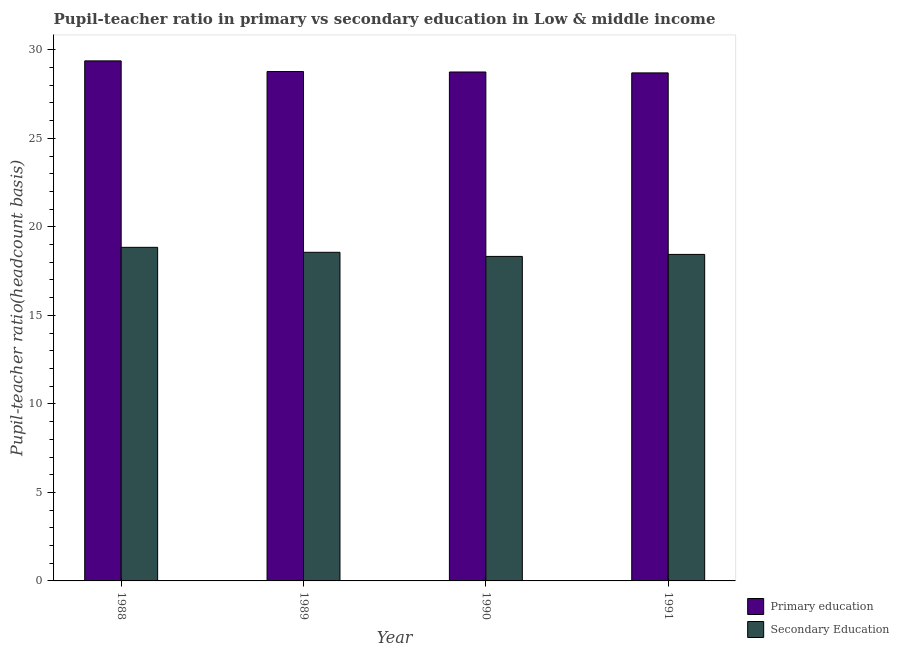How many different coloured bars are there?
Offer a terse response. 2. Are the number of bars per tick equal to the number of legend labels?
Make the answer very short. Yes. Are the number of bars on each tick of the X-axis equal?
Provide a short and direct response. Yes. How many bars are there on the 1st tick from the left?
Ensure brevity in your answer.  2. What is the pupil teacher ratio on secondary education in 1988?
Provide a succinct answer. 18.84. Across all years, what is the maximum pupil-teacher ratio in primary education?
Provide a succinct answer. 29.38. Across all years, what is the minimum pupil-teacher ratio in primary education?
Offer a very short reply. 28.7. What is the total pupil teacher ratio on secondary education in the graph?
Keep it short and to the point. 74.18. What is the difference between the pupil-teacher ratio in primary education in 1989 and that in 1990?
Provide a succinct answer. 0.03. What is the difference between the pupil teacher ratio on secondary education in 1990 and the pupil-teacher ratio in primary education in 1991?
Give a very brief answer. -0.11. What is the average pupil-teacher ratio in primary education per year?
Offer a very short reply. 28.9. In the year 1989, what is the difference between the pupil teacher ratio on secondary education and pupil-teacher ratio in primary education?
Offer a very short reply. 0. What is the ratio of the pupil-teacher ratio in primary education in 1988 to that in 1991?
Ensure brevity in your answer.  1.02. What is the difference between the highest and the second highest pupil-teacher ratio in primary education?
Your answer should be very brief. 0.6. What is the difference between the highest and the lowest pupil-teacher ratio in primary education?
Provide a succinct answer. 0.68. What does the 1st bar from the left in 1991 represents?
Give a very brief answer. Primary education. What does the 1st bar from the right in 1990 represents?
Provide a succinct answer. Secondary Education. How many years are there in the graph?
Ensure brevity in your answer.  4. Does the graph contain any zero values?
Your response must be concise. No. Does the graph contain grids?
Give a very brief answer. No. How many legend labels are there?
Your answer should be compact. 2. How are the legend labels stacked?
Your response must be concise. Vertical. What is the title of the graph?
Give a very brief answer. Pupil-teacher ratio in primary vs secondary education in Low & middle income. Does "Rural" appear as one of the legend labels in the graph?
Make the answer very short. No. What is the label or title of the X-axis?
Provide a succinct answer. Year. What is the label or title of the Y-axis?
Keep it short and to the point. Pupil-teacher ratio(headcount basis). What is the Pupil-teacher ratio(headcount basis) in Primary education in 1988?
Your response must be concise. 29.38. What is the Pupil-teacher ratio(headcount basis) in Secondary Education in 1988?
Your response must be concise. 18.84. What is the Pupil-teacher ratio(headcount basis) of Primary education in 1989?
Your answer should be very brief. 28.78. What is the Pupil-teacher ratio(headcount basis) in Secondary Education in 1989?
Keep it short and to the point. 18.56. What is the Pupil-teacher ratio(headcount basis) of Primary education in 1990?
Ensure brevity in your answer.  28.75. What is the Pupil-teacher ratio(headcount basis) of Secondary Education in 1990?
Your response must be concise. 18.33. What is the Pupil-teacher ratio(headcount basis) of Primary education in 1991?
Ensure brevity in your answer.  28.7. What is the Pupil-teacher ratio(headcount basis) of Secondary Education in 1991?
Provide a short and direct response. 18.44. Across all years, what is the maximum Pupil-teacher ratio(headcount basis) in Primary education?
Your answer should be very brief. 29.38. Across all years, what is the maximum Pupil-teacher ratio(headcount basis) of Secondary Education?
Give a very brief answer. 18.84. Across all years, what is the minimum Pupil-teacher ratio(headcount basis) of Primary education?
Your answer should be very brief. 28.7. Across all years, what is the minimum Pupil-teacher ratio(headcount basis) in Secondary Education?
Make the answer very short. 18.33. What is the total Pupil-teacher ratio(headcount basis) of Primary education in the graph?
Your answer should be compact. 115.6. What is the total Pupil-teacher ratio(headcount basis) in Secondary Education in the graph?
Offer a terse response. 74.18. What is the difference between the Pupil-teacher ratio(headcount basis) of Primary education in 1988 and that in 1989?
Your answer should be compact. 0.6. What is the difference between the Pupil-teacher ratio(headcount basis) of Secondary Education in 1988 and that in 1989?
Offer a very short reply. 0.28. What is the difference between the Pupil-teacher ratio(headcount basis) in Primary education in 1988 and that in 1990?
Provide a succinct answer. 0.63. What is the difference between the Pupil-teacher ratio(headcount basis) in Secondary Education in 1988 and that in 1990?
Provide a short and direct response. 0.51. What is the difference between the Pupil-teacher ratio(headcount basis) of Primary education in 1988 and that in 1991?
Make the answer very short. 0.68. What is the difference between the Pupil-teacher ratio(headcount basis) of Secondary Education in 1988 and that in 1991?
Make the answer very short. 0.4. What is the difference between the Pupil-teacher ratio(headcount basis) of Primary education in 1989 and that in 1990?
Your response must be concise. 0.03. What is the difference between the Pupil-teacher ratio(headcount basis) in Secondary Education in 1989 and that in 1990?
Offer a very short reply. 0.23. What is the difference between the Pupil-teacher ratio(headcount basis) in Primary education in 1989 and that in 1991?
Keep it short and to the point. 0.08. What is the difference between the Pupil-teacher ratio(headcount basis) of Secondary Education in 1989 and that in 1991?
Ensure brevity in your answer.  0.12. What is the difference between the Pupil-teacher ratio(headcount basis) in Primary education in 1990 and that in 1991?
Your response must be concise. 0.05. What is the difference between the Pupil-teacher ratio(headcount basis) of Secondary Education in 1990 and that in 1991?
Provide a short and direct response. -0.11. What is the difference between the Pupil-teacher ratio(headcount basis) of Primary education in 1988 and the Pupil-teacher ratio(headcount basis) of Secondary Education in 1989?
Keep it short and to the point. 10.81. What is the difference between the Pupil-teacher ratio(headcount basis) of Primary education in 1988 and the Pupil-teacher ratio(headcount basis) of Secondary Education in 1990?
Provide a succinct answer. 11.05. What is the difference between the Pupil-teacher ratio(headcount basis) in Primary education in 1988 and the Pupil-teacher ratio(headcount basis) in Secondary Education in 1991?
Your answer should be compact. 10.93. What is the difference between the Pupil-teacher ratio(headcount basis) of Primary education in 1989 and the Pupil-teacher ratio(headcount basis) of Secondary Education in 1990?
Provide a short and direct response. 10.44. What is the difference between the Pupil-teacher ratio(headcount basis) of Primary education in 1989 and the Pupil-teacher ratio(headcount basis) of Secondary Education in 1991?
Offer a very short reply. 10.33. What is the difference between the Pupil-teacher ratio(headcount basis) in Primary education in 1990 and the Pupil-teacher ratio(headcount basis) in Secondary Education in 1991?
Offer a very short reply. 10.31. What is the average Pupil-teacher ratio(headcount basis) in Primary education per year?
Offer a very short reply. 28.9. What is the average Pupil-teacher ratio(headcount basis) in Secondary Education per year?
Your answer should be very brief. 18.55. In the year 1988, what is the difference between the Pupil-teacher ratio(headcount basis) in Primary education and Pupil-teacher ratio(headcount basis) in Secondary Education?
Provide a succinct answer. 10.53. In the year 1989, what is the difference between the Pupil-teacher ratio(headcount basis) of Primary education and Pupil-teacher ratio(headcount basis) of Secondary Education?
Keep it short and to the point. 10.21. In the year 1990, what is the difference between the Pupil-teacher ratio(headcount basis) of Primary education and Pupil-teacher ratio(headcount basis) of Secondary Education?
Your answer should be very brief. 10.42. In the year 1991, what is the difference between the Pupil-teacher ratio(headcount basis) in Primary education and Pupil-teacher ratio(headcount basis) in Secondary Education?
Your answer should be very brief. 10.25. What is the ratio of the Pupil-teacher ratio(headcount basis) of Primary education in 1988 to that in 1989?
Provide a short and direct response. 1.02. What is the ratio of the Pupil-teacher ratio(headcount basis) in Secondary Education in 1988 to that in 1989?
Your response must be concise. 1.02. What is the ratio of the Pupil-teacher ratio(headcount basis) in Primary education in 1988 to that in 1990?
Keep it short and to the point. 1.02. What is the ratio of the Pupil-teacher ratio(headcount basis) of Secondary Education in 1988 to that in 1990?
Offer a terse response. 1.03. What is the ratio of the Pupil-teacher ratio(headcount basis) in Primary education in 1988 to that in 1991?
Your answer should be very brief. 1.02. What is the ratio of the Pupil-teacher ratio(headcount basis) of Secondary Education in 1988 to that in 1991?
Ensure brevity in your answer.  1.02. What is the ratio of the Pupil-teacher ratio(headcount basis) in Primary education in 1989 to that in 1990?
Offer a terse response. 1. What is the ratio of the Pupil-teacher ratio(headcount basis) in Secondary Education in 1989 to that in 1990?
Make the answer very short. 1.01. What is the ratio of the Pupil-teacher ratio(headcount basis) of Primary education in 1990 to that in 1991?
Offer a terse response. 1. What is the difference between the highest and the second highest Pupil-teacher ratio(headcount basis) of Primary education?
Offer a terse response. 0.6. What is the difference between the highest and the second highest Pupil-teacher ratio(headcount basis) in Secondary Education?
Provide a short and direct response. 0.28. What is the difference between the highest and the lowest Pupil-teacher ratio(headcount basis) of Primary education?
Your response must be concise. 0.68. What is the difference between the highest and the lowest Pupil-teacher ratio(headcount basis) of Secondary Education?
Make the answer very short. 0.51. 